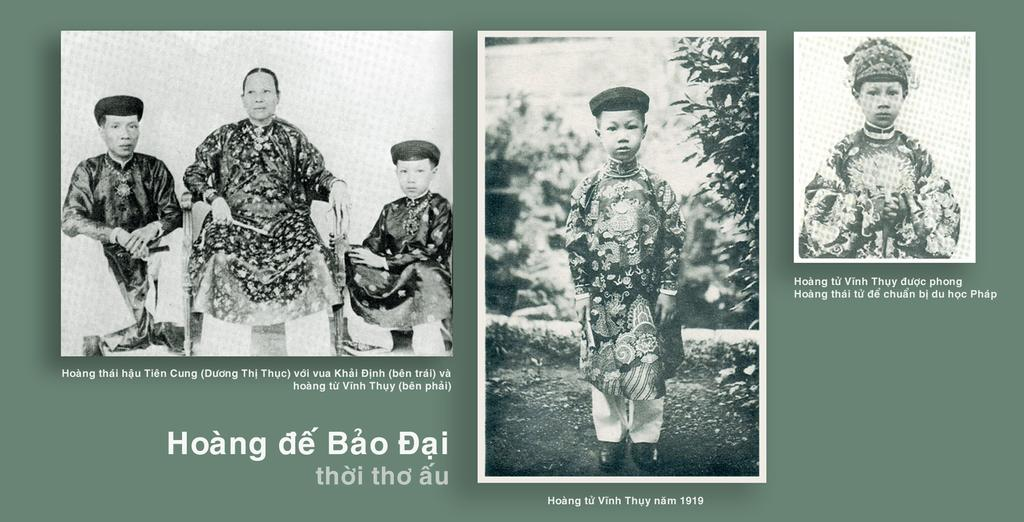What is the color scheme of the image? The image is a black and white collage. What type of content is included in the collage? The collage contains pictures of a person. How does the person in the collage attempt to control their anger? There is no indication of the person's emotions or actions in the image, as it is a black and white collage containing pictures of a person. 